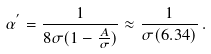Convert formula to latex. <formula><loc_0><loc_0><loc_500><loc_500>\alpha ^ { ^ { \prime } } = { \frac { 1 } { 8 \sigma ( 1 - { \frac { A } { \sigma } } ) } } \approx { \frac { 1 } { \sigma ( 6 . 3 4 ) } } \, .</formula> 